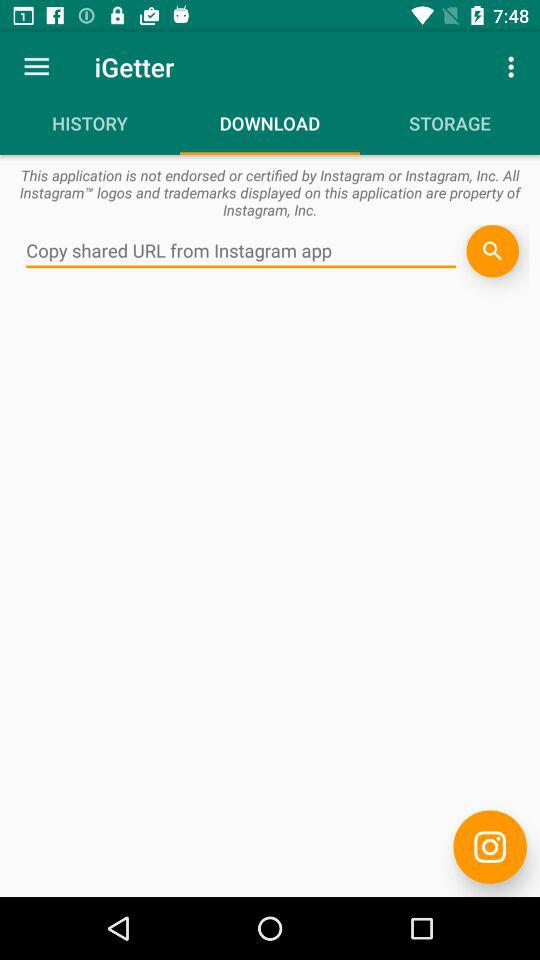What is the application name? The application name is "iGetter". 